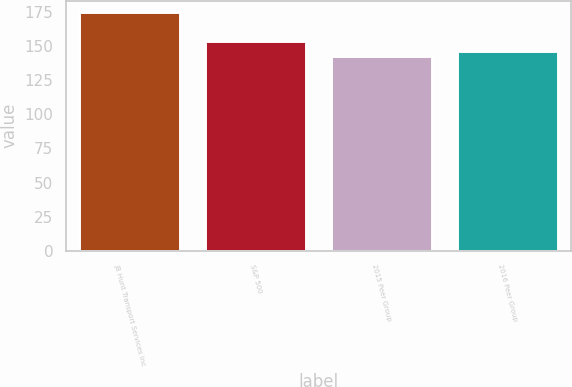Convert chart to OTSL. <chart><loc_0><loc_0><loc_500><loc_500><bar_chart><fcel>JB Hunt Transport Services Inc<fcel>S&P 500<fcel>2015 Peer Group<fcel>2016 Peer Group<nl><fcel>174.78<fcel>153.58<fcel>143.03<fcel>146.21<nl></chart> 